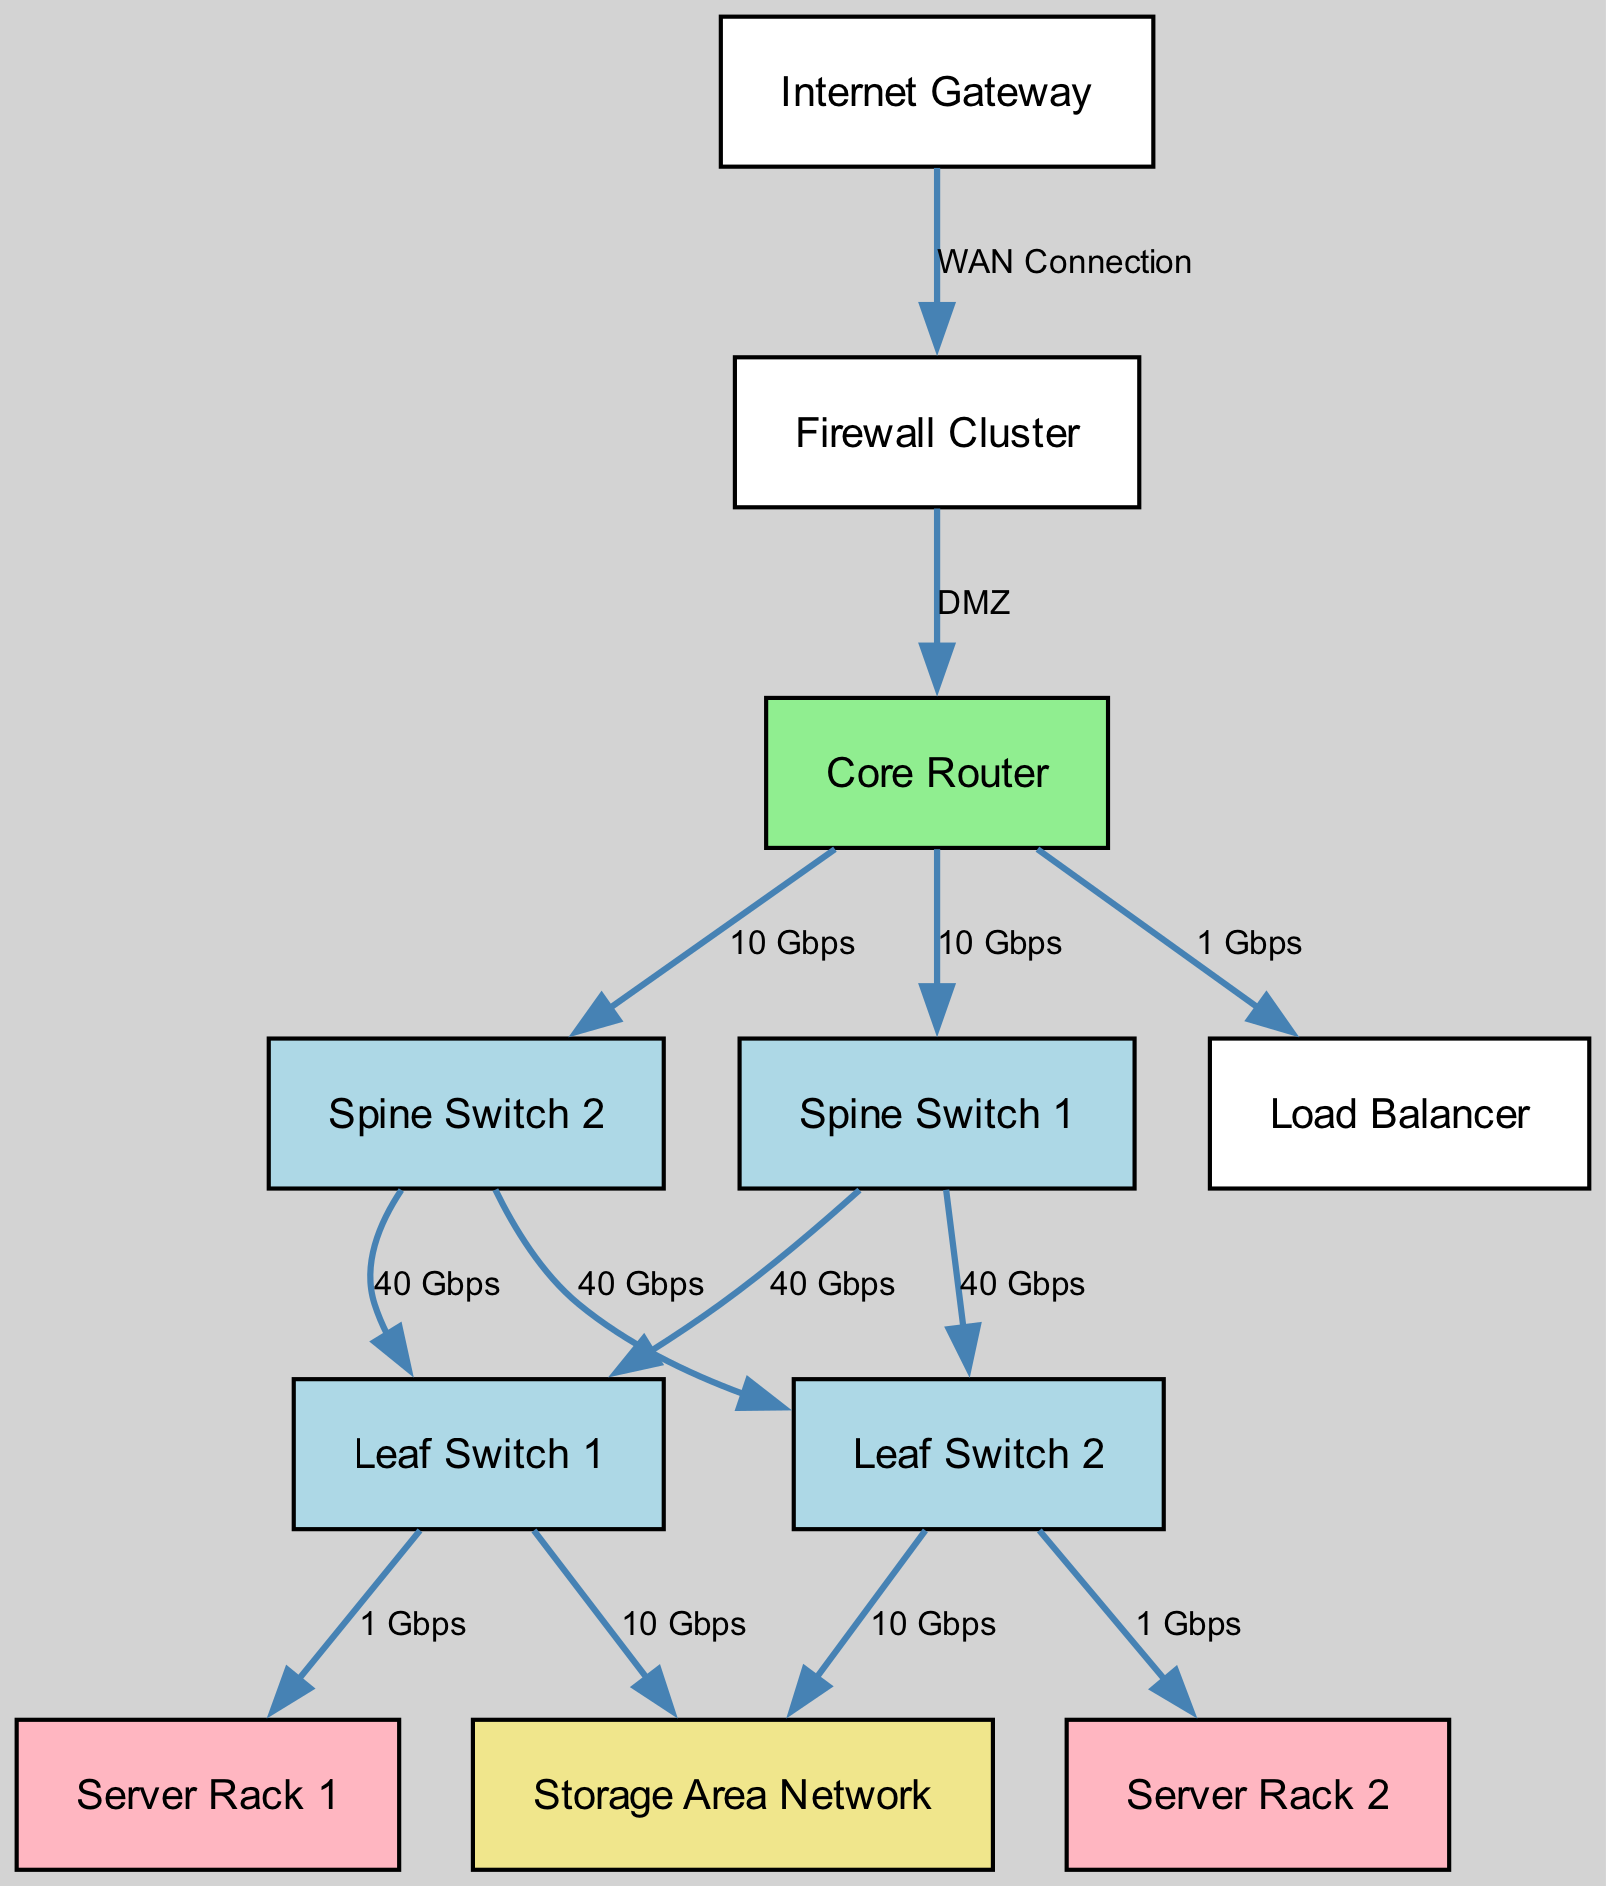What is the total number of nodes in the diagram? The diagram lists 11 nodes, each representing a component of the data center infrastructure such as gateways, routers, switches, racks, and storage.
Answer: 11 What type of connection is used between the Internet Gateway and Firewall Cluster? The edge from the Internet Gateway to the Firewall Cluster is labeled as a WAN Connection, which indicates the type of connection.
Answer: WAN Connection How many connections are there coming from the Core Router? The Core Router has three outgoing connections: two to Spine Switches and one to the Load Balancer, totaling three connections.
Answer: 3 What is the bandwidth of the connection between Spine Switch 1 and Leaf Switch 1? The connection from Spine Switch 1 to Leaf Switch 1 is labeled as 40 Gbps, indicating the bandwidth for that link.
Answer: 40 Gbps Which node connects directly to both Leaf Switch 1 and the Storage Area Network? Leaf Switch 1 has two connections: one to Server Rack 1 and the other to the Storage Area Network, indicating it serves two components.
Answer: Storage Area Network What is the bandwidth of the connection between the Core Router and Load Balancer? The edge from the Core Router to the Load Balancer is labeled as 1 Gbps, which indicates the bandwidth for that connection.
Answer: 1 Gbps Which two nodes connect directly to Spine Switch 2? Spine Switch 2 connects directly to Leaf Switch 2 and Core Router, indicating its role in the network topology between them.
Answer: Leaf Switch 2 and Core Router What percentage of the total incoming connections to the Core Router has a bandwidth of 10 Gbps? The Core Router has two incoming connections of 10 Gbps out of a total of three, representing approximately 66.7% of its total connections.
Answer: 66.7% How many server racks are connected to Leaf Switch 2? Leaf Switch 2 connects directly to Server Rack 2, making it the only server rack linked to that switch.
Answer: 1 